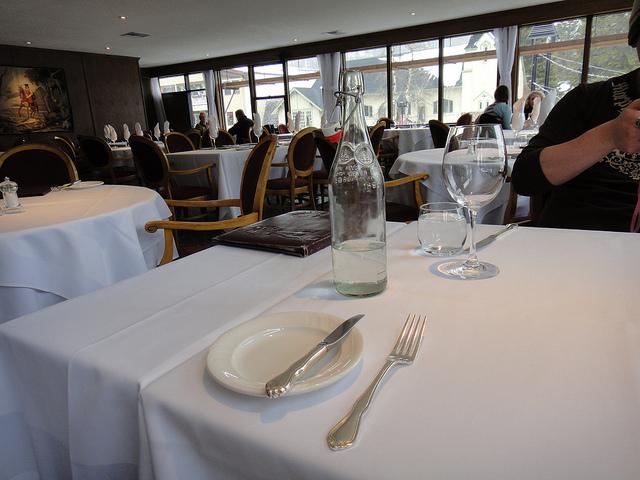The tablecloths are white?
Answer briefly. Yes. What silverware is on the table?
Concise answer only. Knife and fork. Where do you think all these are located?
Quick response, please. Restaurant. What color is the knife handle?
Answer briefly. Silver. Are the pictures colorful?
Write a very short answer. Yes. Do you a mirror in the background?
Keep it brief. No. How many glasses are there?
Be succinct. 2. Is there food on the table?
Quick response, please. No. Where is the room?
Be succinct. Restaurant. 